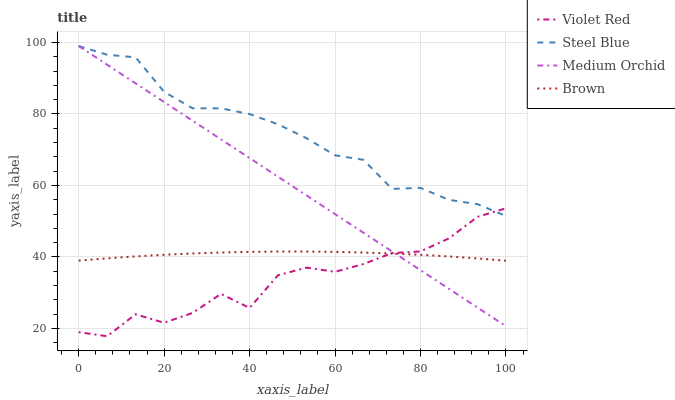Does Violet Red have the minimum area under the curve?
Answer yes or no. Yes. Does Steel Blue have the maximum area under the curve?
Answer yes or no. Yes. Does Medium Orchid have the minimum area under the curve?
Answer yes or no. No. Does Medium Orchid have the maximum area under the curve?
Answer yes or no. No. Is Medium Orchid the smoothest?
Answer yes or no. Yes. Is Violet Red the roughest?
Answer yes or no. Yes. Is Violet Red the smoothest?
Answer yes or no. No. Is Medium Orchid the roughest?
Answer yes or no. No. Does Violet Red have the lowest value?
Answer yes or no. Yes. Does Medium Orchid have the lowest value?
Answer yes or no. No. Does Medium Orchid have the highest value?
Answer yes or no. Yes. Does Violet Red have the highest value?
Answer yes or no. No. Is Brown less than Steel Blue?
Answer yes or no. Yes. Is Steel Blue greater than Brown?
Answer yes or no. Yes. Does Medium Orchid intersect Brown?
Answer yes or no. Yes. Is Medium Orchid less than Brown?
Answer yes or no. No. Is Medium Orchid greater than Brown?
Answer yes or no. No. Does Brown intersect Steel Blue?
Answer yes or no. No. 